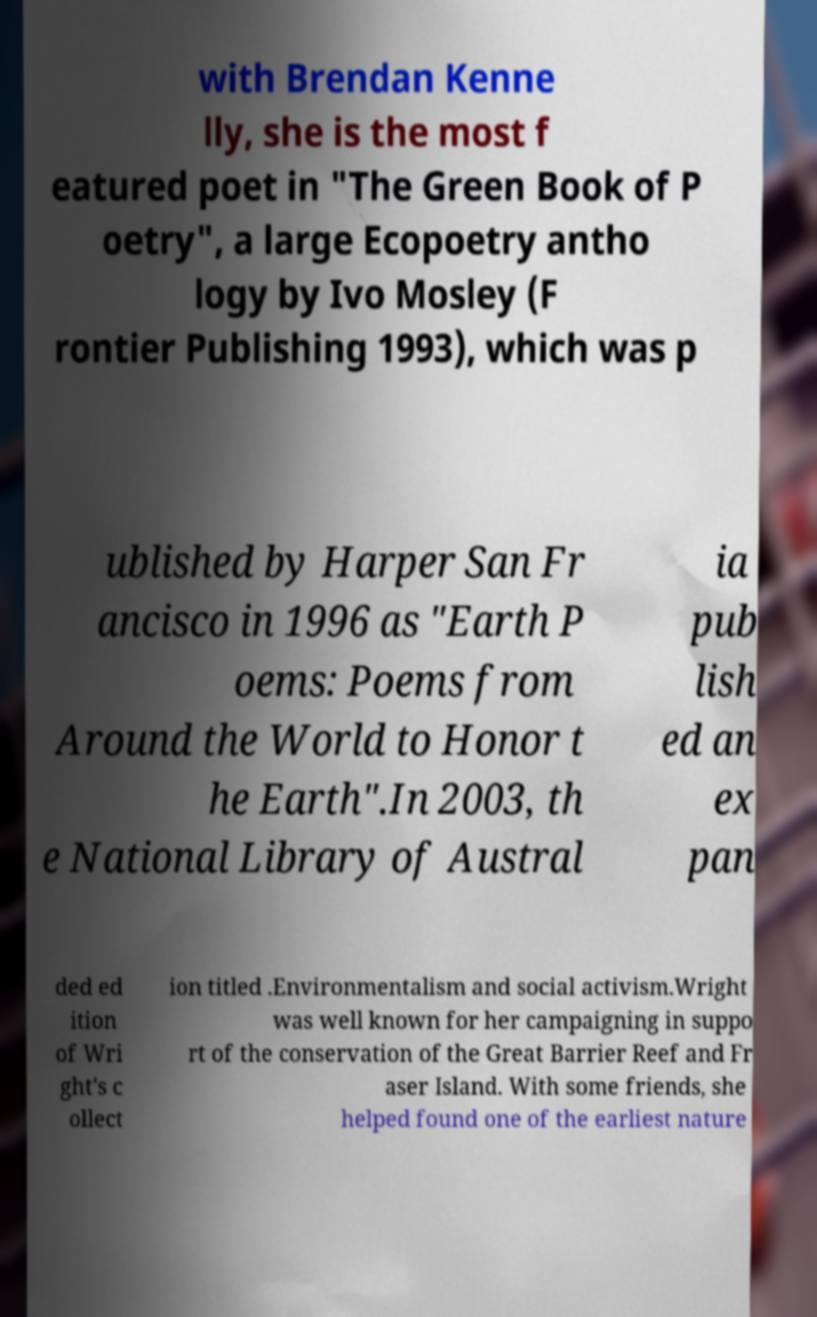I need the written content from this picture converted into text. Can you do that? with Brendan Kenne lly, she is the most f eatured poet in "The Green Book of P oetry", a large Ecopoetry antho logy by Ivo Mosley (F rontier Publishing 1993), which was p ublished by Harper San Fr ancisco in 1996 as "Earth P oems: Poems from Around the World to Honor t he Earth".In 2003, th e National Library of Austral ia pub lish ed an ex pan ded ed ition of Wri ght's c ollect ion titled .Environmentalism and social activism.Wright was well known for her campaigning in suppo rt of the conservation of the Great Barrier Reef and Fr aser Island. With some friends, she helped found one of the earliest nature 